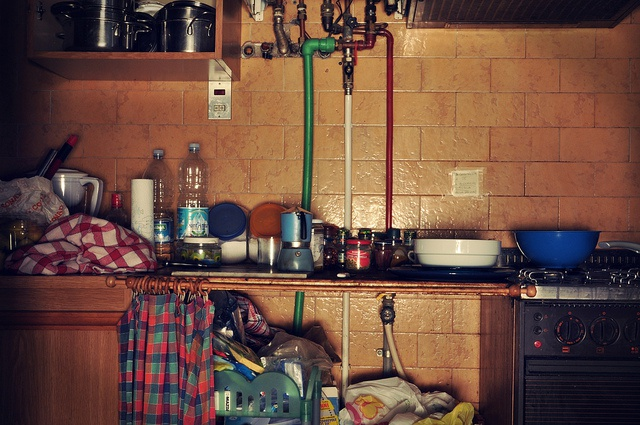Describe the objects in this image and their specific colors. I can see oven in black and gray tones, bowl in black, navy, darkblue, and blue tones, bottle in black, brown, maroon, and gray tones, bowl in black, tan, and gray tones, and bottle in black, maroon, brown, and gray tones in this image. 